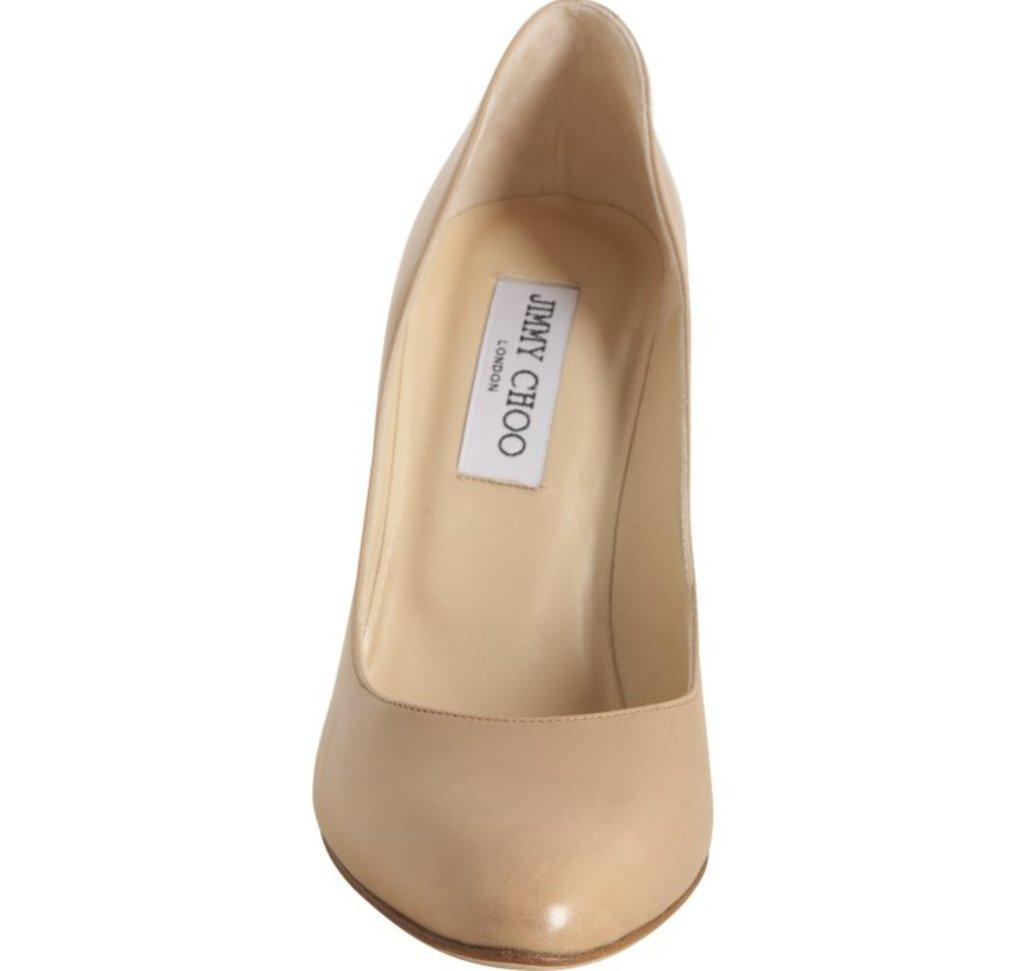What type of clothing item is the main focus of the image? The image depicts women's footwear. Can you describe the footwear in more detail? Unfortunately, the provided facts do not offer any additional details about the footwear. Are there any other objects or people visible in the image? The given facts only mention women's footwear, so there is no information about any other elements in the image. What type of berry can be seen growing in the garden depicted in the image? There is no garden or berry present in the image; it only features women's footwear. 